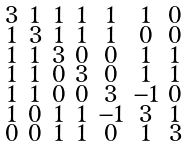Convert formula to latex. <formula><loc_0><loc_0><loc_500><loc_500>\begin{smallmatrix} 3 & 1 & 1 & 1 & 1 & 1 & 0 \\ 1 & 3 & 1 & 1 & 1 & 0 & 0 \\ 1 & 1 & 3 & 0 & 0 & 1 & 1 \\ 1 & 1 & 0 & 3 & 0 & 1 & 1 \\ 1 & 1 & 0 & 0 & 3 & - 1 & 0 \\ 1 & 0 & 1 & 1 & - 1 & 3 & 1 \\ 0 & 0 & 1 & 1 & 0 & 1 & 3 \end{smallmatrix}</formula> 